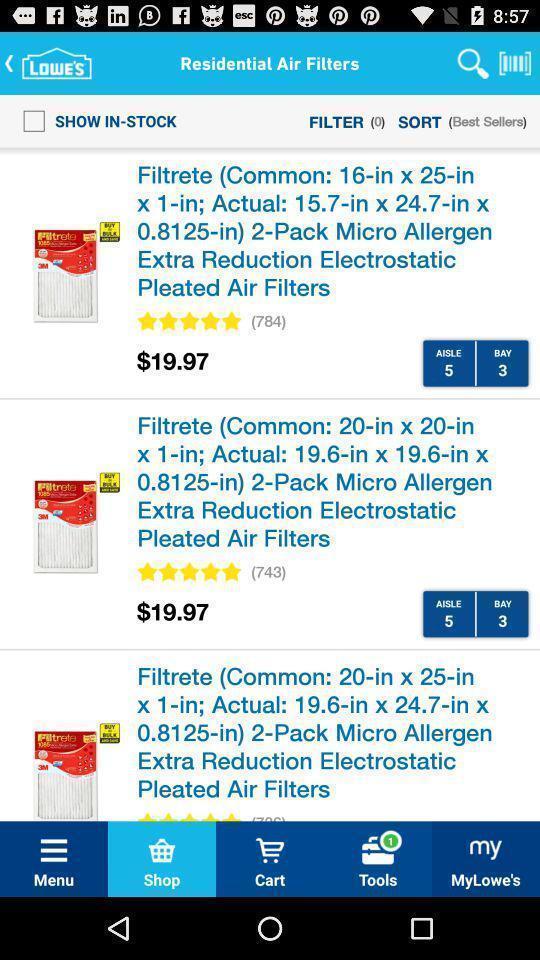Explain the elements present in this screenshot. Shopping app displayed different items and other options. 